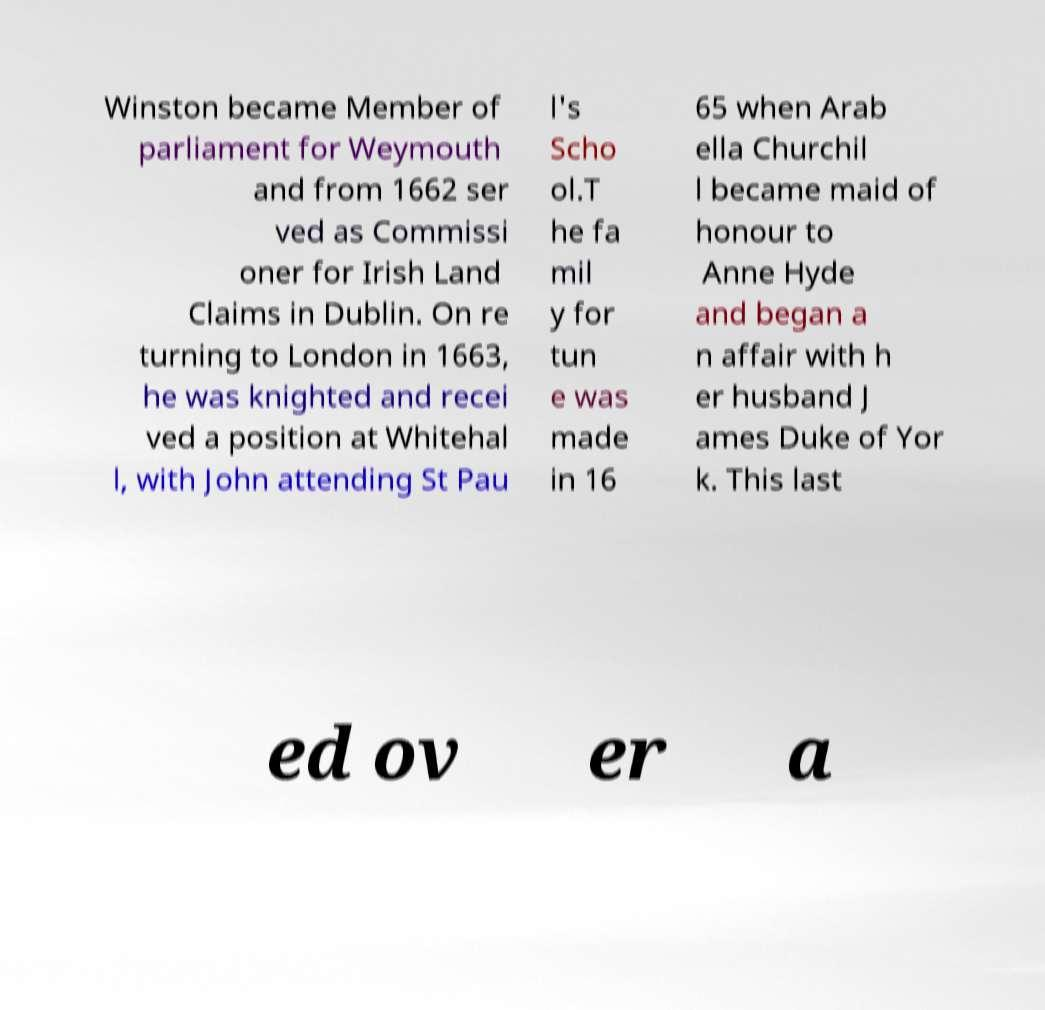Please read and relay the text visible in this image. What does it say? Winston became Member of parliament for Weymouth and from 1662 ser ved as Commissi oner for Irish Land Claims in Dublin. On re turning to London in 1663, he was knighted and recei ved a position at Whitehal l, with John attending St Pau l's Scho ol.T he fa mil y for tun e was made in 16 65 when Arab ella Churchil l became maid of honour to Anne Hyde and began a n affair with h er husband J ames Duke of Yor k. This last ed ov er a 